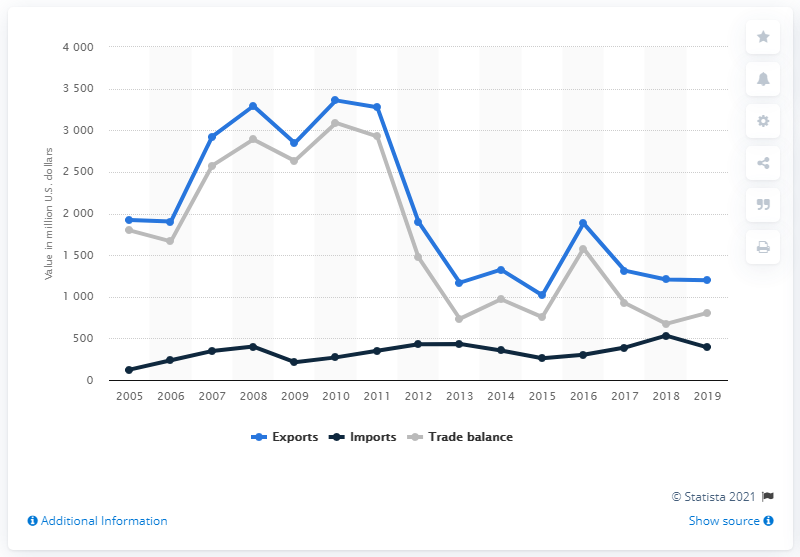Give some essential details in this illustration. In 2019, the value of Russian imports of goods from Iran was 391.36 million US dollars. In 2019, the value of Russian merchandise exports to Iran was 1197.54 million dollars. 